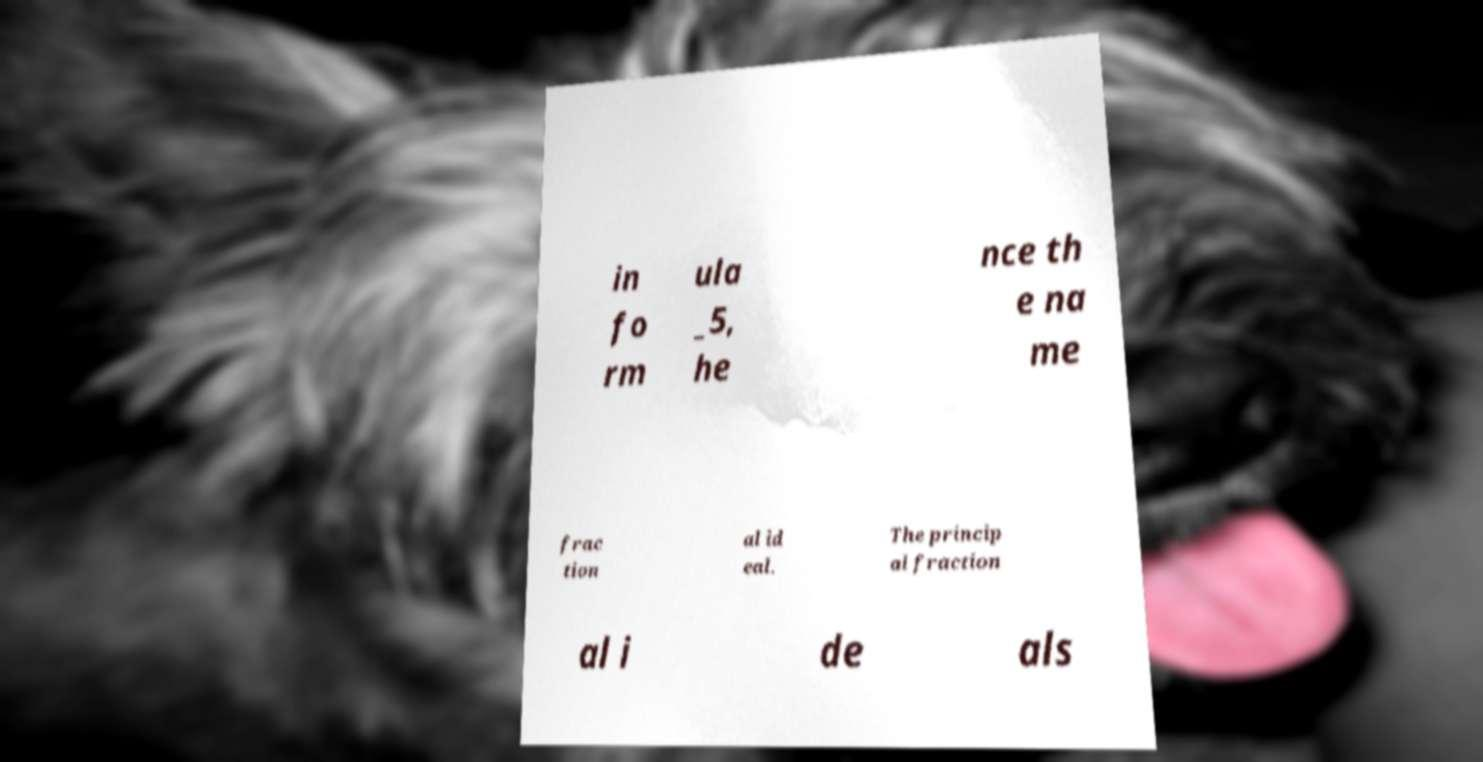I need the written content from this picture converted into text. Can you do that? in fo rm ula _5, he nce th e na me frac tion al id eal. The princip al fraction al i de als 